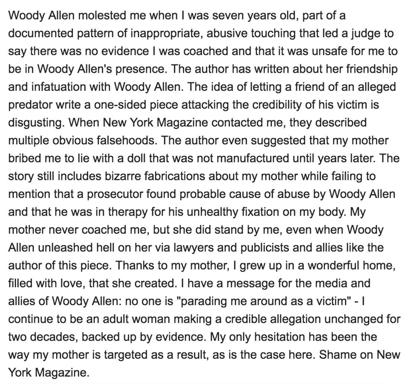What is the main subject of the text in the image?
 The main subject of the text is the author's accusation that Woody Allen molested her when she was seven years old and the criticism of a one-sided article written by a friend of Woody Allen, published in New York Magazine. What are some of the criticisms leveled against the New York Magazine piece? The author criticizes the New York Magazine piece for including multiple obvious falsehoods, suggesting that her mother bribed her with a doll that wasn't manufactured until years later, and including bizarre fabrications about her mother. Additionally, she points out that the piece fails to mention that a prosecutor found probable cause of abuse by Woody Allen. What message does the author want to convey to the media and allies of Woody Allen? The author's message for the media and allies of Woody Allen is that they should not parade her around as a victim, as she continues to be an adult woman making a credible allegation unchanged for two decades and backed up by evidence. She expresses her frustration with the way her mother has been targeted as a result of her accusation. 